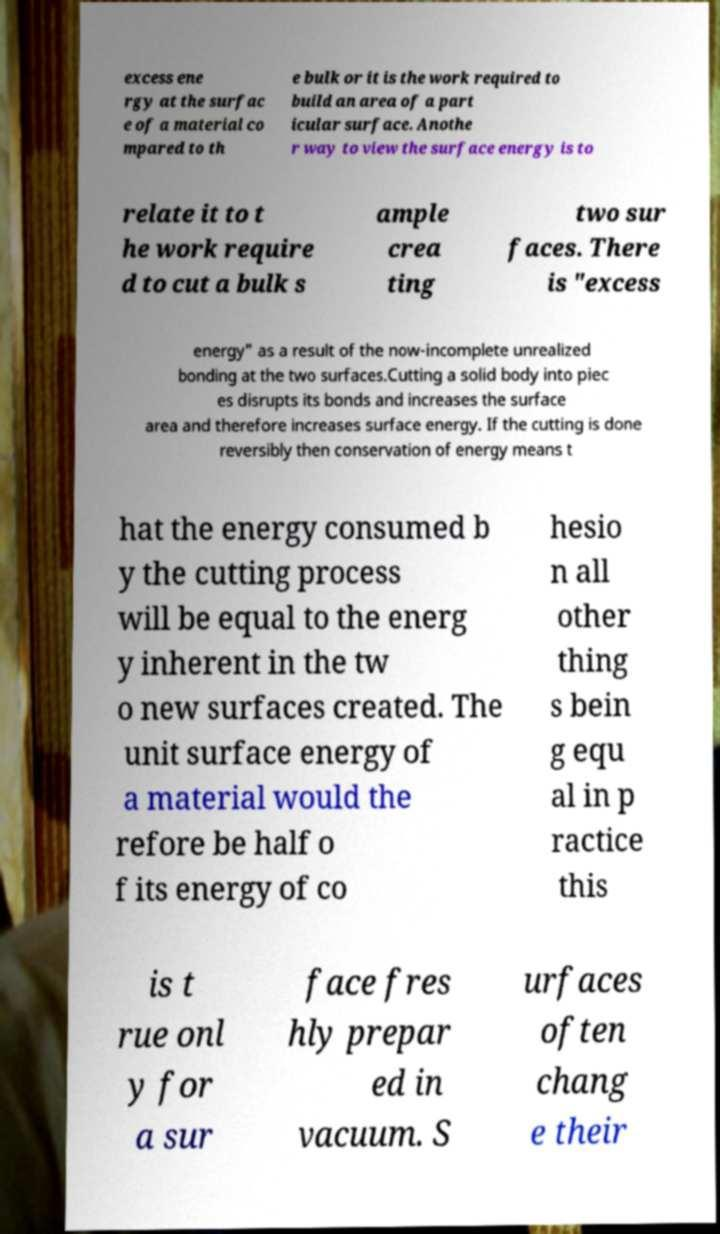Please identify and transcribe the text found in this image. excess ene rgy at the surfac e of a material co mpared to th e bulk or it is the work required to build an area of a part icular surface. Anothe r way to view the surface energy is to relate it to t he work require d to cut a bulk s ample crea ting two sur faces. There is "excess energy" as a result of the now-incomplete unrealized bonding at the two surfaces.Cutting a solid body into piec es disrupts its bonds and increases the surface area and therefore increases surface energy. If the cutting is done reversibly then conservation of energy means t hat the energy consumed b y the cutting process will be equal to the energ y inherent in the tw o new surfaces created. The unit surface energy of a material would the refore be half o f its energy of co hesio n all other thing s bein g equ al in p ractice this is t rue onl y for a sur face fres hly prepar ed in vacuum. S urfaces often chang e their 